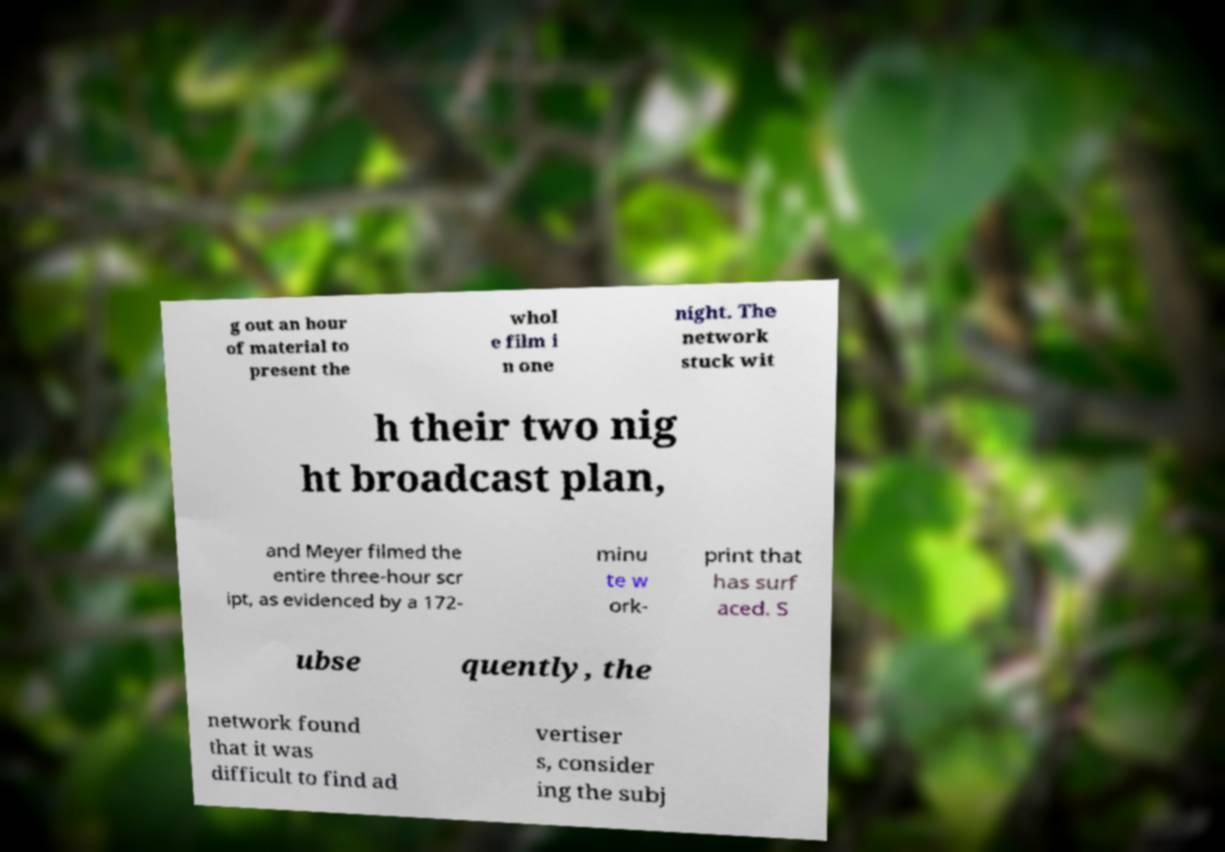What messages or text are displayed in this image? I need them in a readable, typed format. g out an hour of material to present the whol e film i n one night. The network stuck wit h their two nig ht broadcast plan, and Meyer filmed the entire three-hour scr ipt, as evidenced by a 172- minu te w ork- print that has surf aced. S ubse quently, the network found that it was difficult to find ad vertiser s, consider ing the subj 